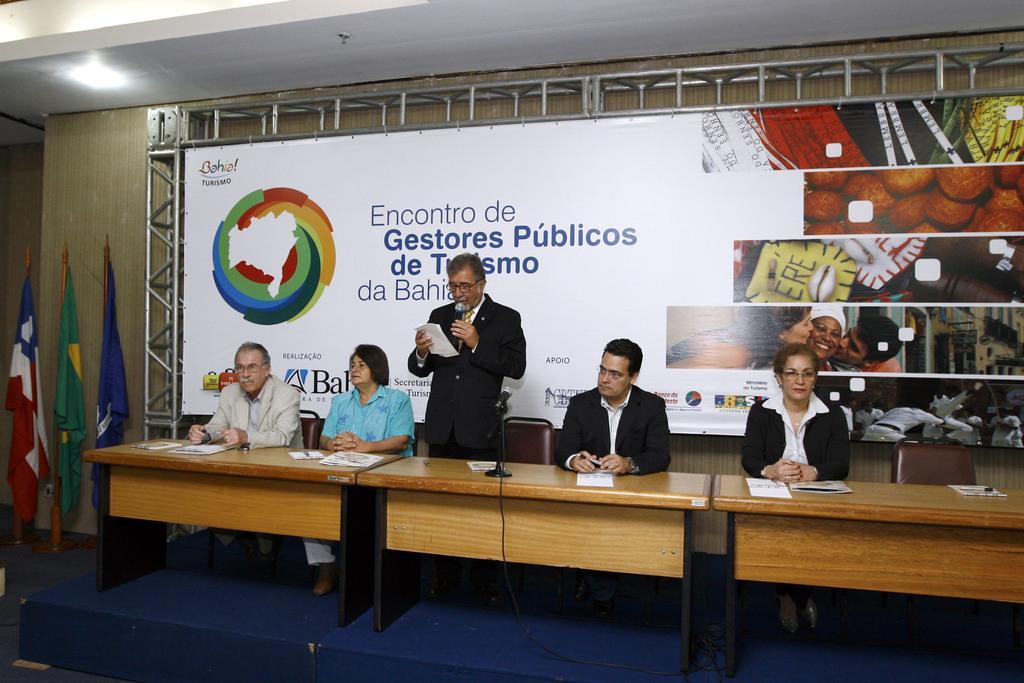Please provide a concise description of this image. On this blue stage there are tables, chairs and a banner. These four persons are sitting on chairs, in middle a person is standing and holding a mic and paper. On this table there is a mic, papers and book. At left side of the image there are three flags. 